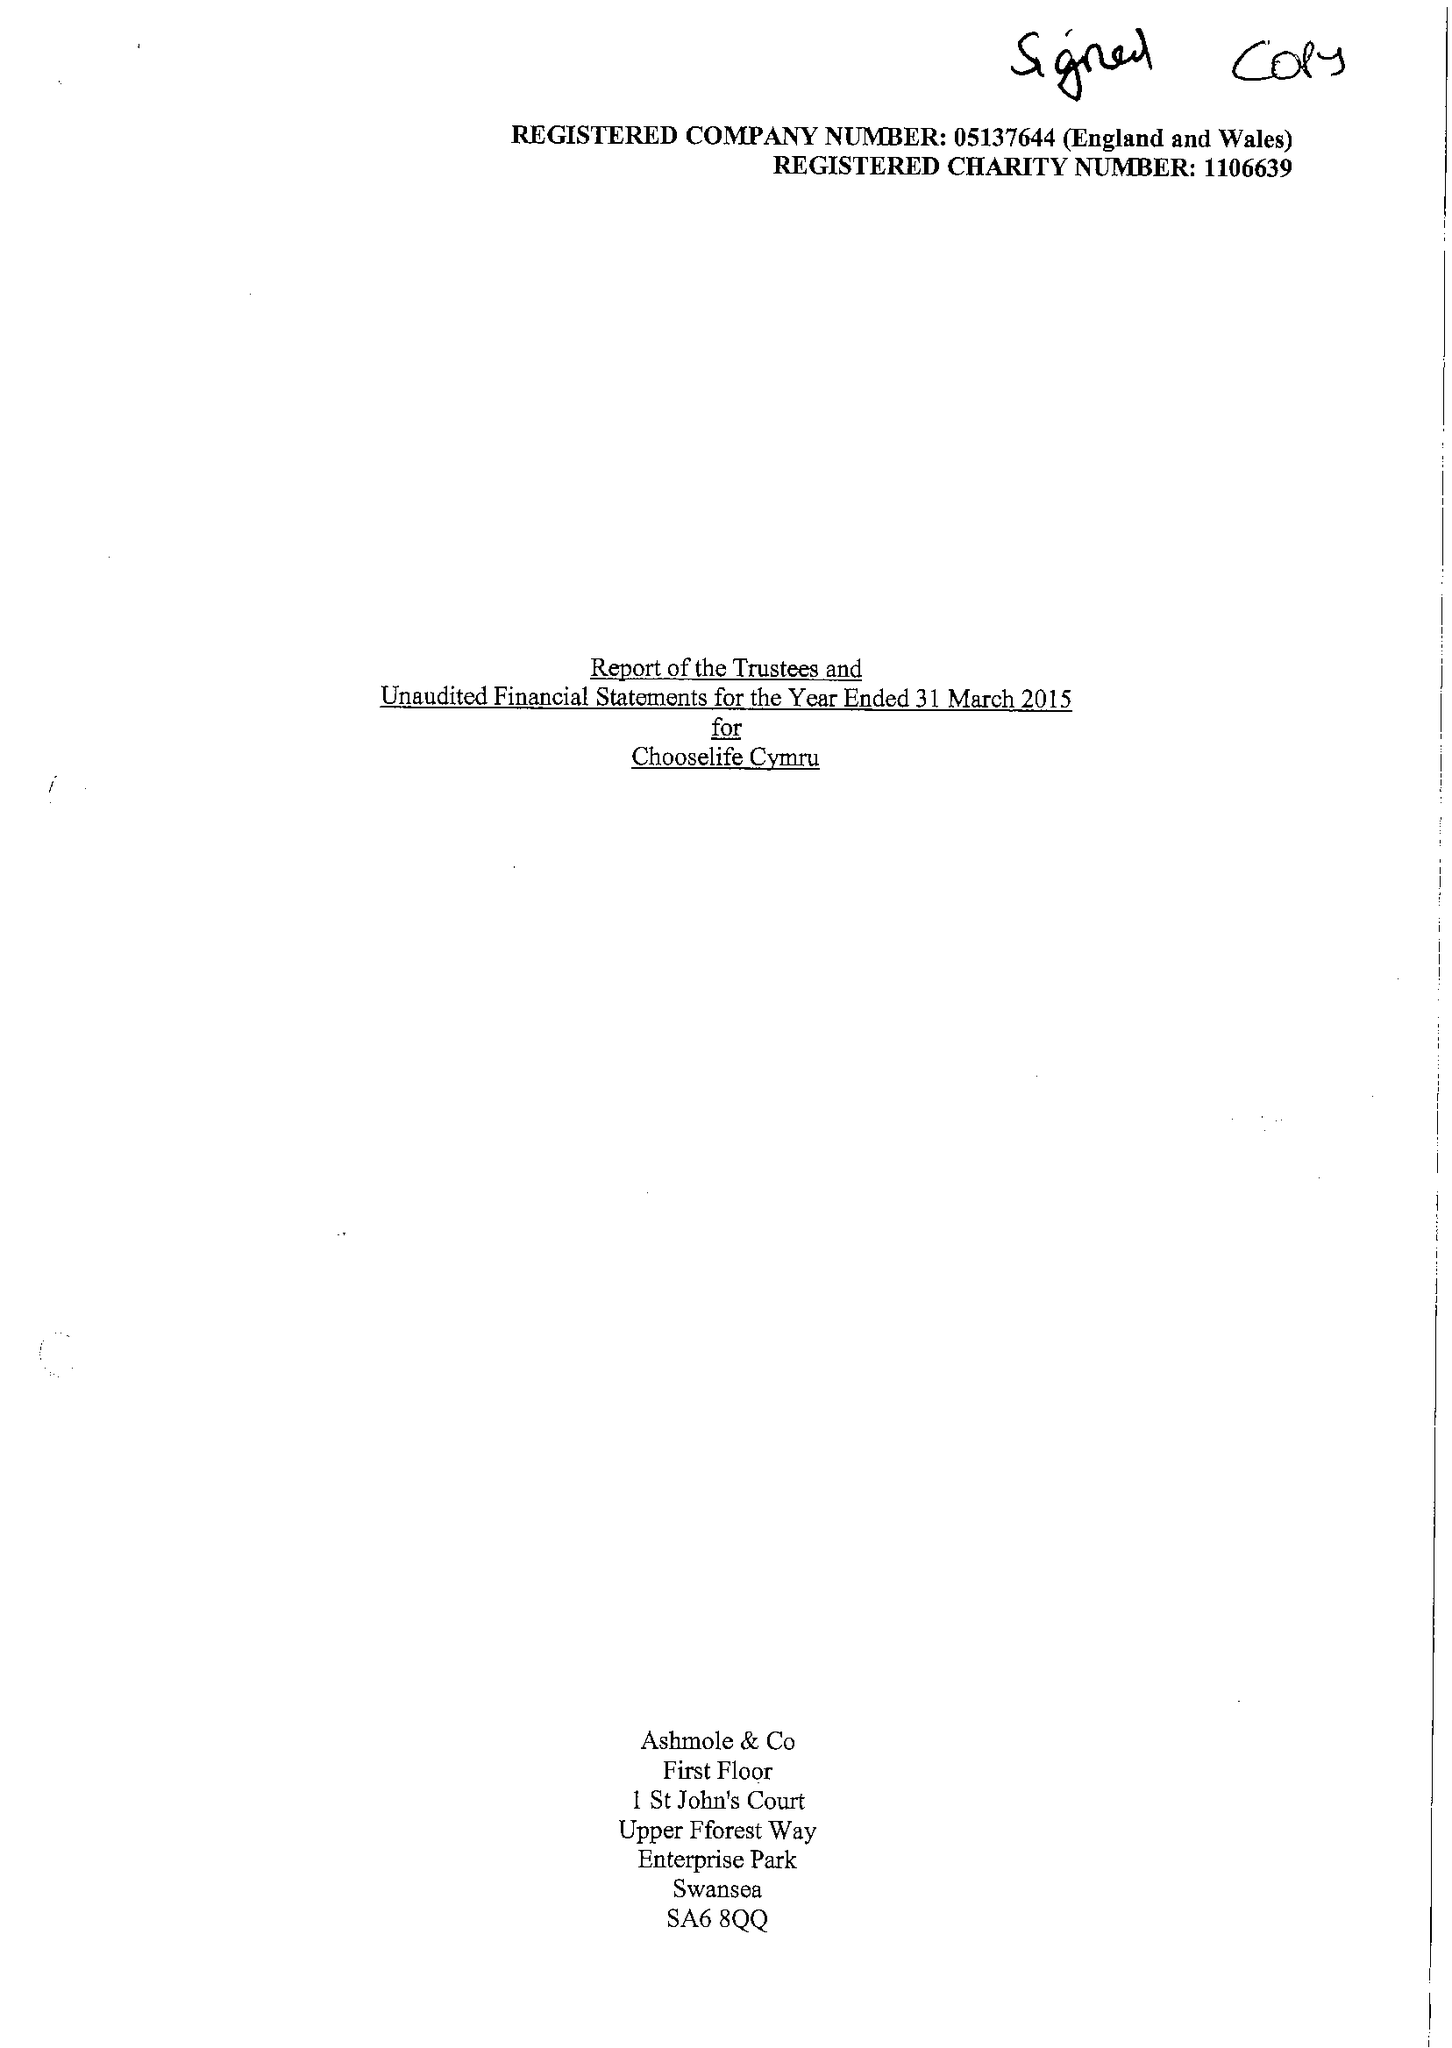What is the value for the charity_name?
Answer the question using a single word or phrase. Chooselife Cymru 